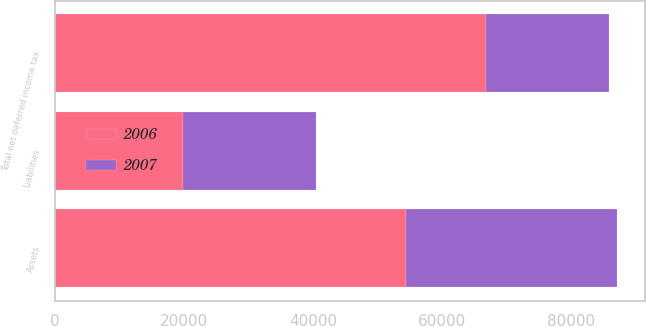<chart> <loc_0><loc_0><loc_500><loc_500><stacked_bar_chart><ecel><fcel>Assets<fcel>Liabilities<fcel>Total net deferred income tax<nl><fcel>2007<fcel>32695<fcel>20503<fcel>18948<nl><fcel>2006<fcel>54431<fcel>19934<fcel>66919<nl></chart> 